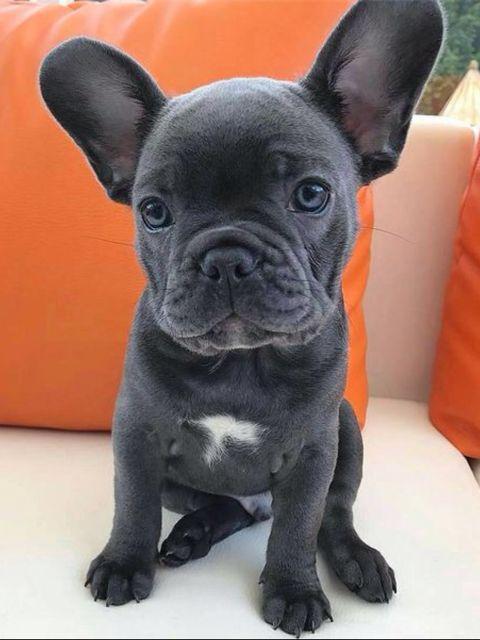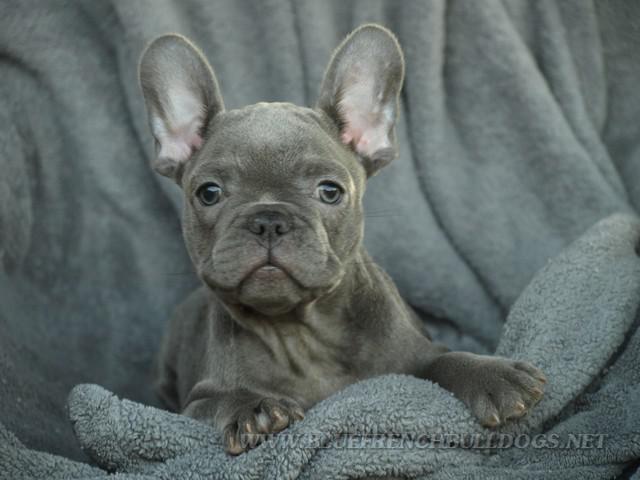The first image is the image on the left, the second image is the image on the right. Given the left and right images, does the statement "The dog in the image on the right is standing up on all four feet." hold true? Answer yes or no. No. 